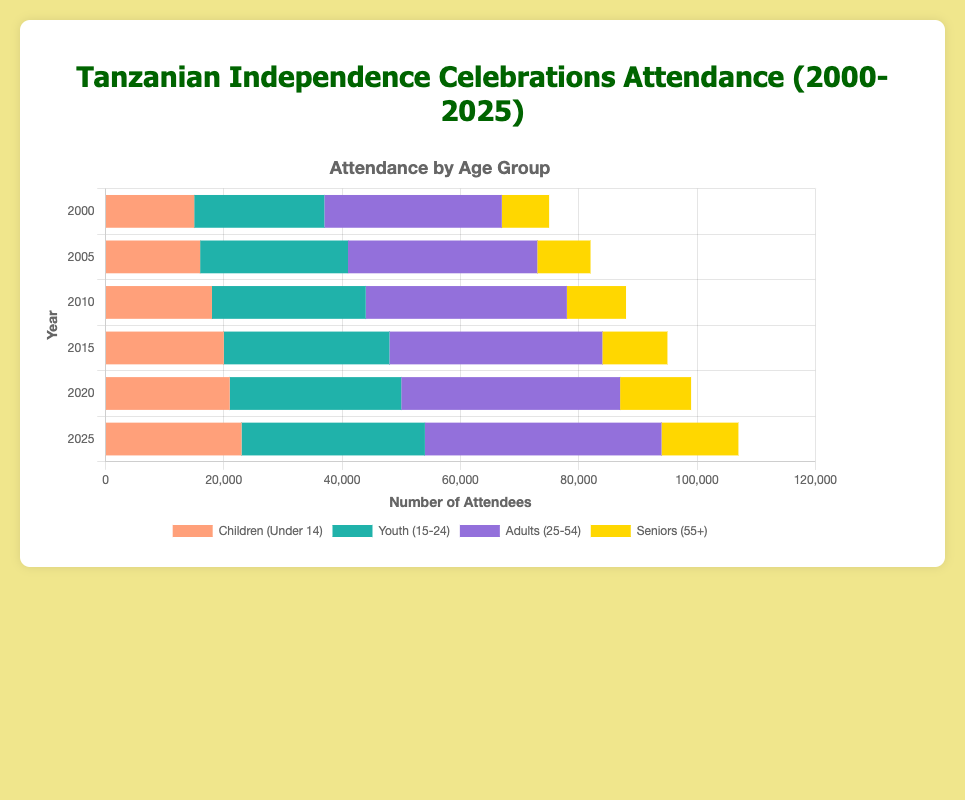What is the total attendance in the year 2010? To find the total attendance for 2010, sum the number of attendees in each age group: 18,000 (Children) + 26,000 (Youth) + 34,000 (Adults) + 10,000 (Seniors) = 88,000.
Answer: 88,000 Which age group had the highest number of attendees in 2020? In 2020, the number of attendees for each age group is: Children: 21,000, Youth: 29,000, Adults: 37,000, Seniors: 12,000. The highest attendance is among Adults with 37,000 attendees.
Answer: Adults How did the attendance of children under 14 change from 2005 to 2025? The attendance of children in 2005 was 16,000, and in 2025 it was 23,000. The change in attendance is 23,000 - 16,000 = 7,000.
Answer: Increased by 7,000 What is the average attendance for seniors (55+) over the years presented? To find the average, first sum the attendance numbers for seniors across all years: 8,000 (2000) + 9,000 (2005) + 10,000 (2010) + 11,000 (2015) + 12,000 (2020) + 13,000 (2025) = 63,000. Then divide by the number of years (6): 63,000 / 6 = 10,500.
Answer: 10,500 Between 2010 and 2015, which age group saw the largest increase in attendance? Calculate the attendance increase for each age group: Children: 20,000 - 18,000 = 2,000, Youth: 28,000 - 26,000 = 2,000, Adults: 36,000 - 34,000 = 2,000, Seniors: 11,000 - 10,000 = 1,000. The largest increase is 2,000, which is tied between Children, Youth, and Adults.
Answer: Children, Youth, and Adults (tie) What percentage of the total attendance in 2025 were adults (25-54)? First, calculate the total attendance in 2025: 23,000 (Children) + 31,000 (Youth) + 40,000 (Adults) + 13,000 (Seniors) = 107,000. Then find the percentage for adults: (40,000/107,000) * 100 ≈ 37.38%.
Answer: 37.38% Compare the number of children under 14 in 2000 and 2025. Which year had more attendees and by how much? In 2000, there were 15,000 children and in 2025 there were 23,000 children. The difference is 23,000 - 15,000 = 8,000. Thus, 2025 had more attendees by 8,000.
Answer: 2025 by 8,000 Which age group had the smallest increase in attendance from 2000 to 2025? Calculate the increase for each age group from 2000 to 2025: Children: 23,000 - 15,000 = 8,000, Youth: 31,000 - 22,000 = 9,000, Adults: 40,000 - 30,000 = 10,000, Seniors: 13,000 - 8,000 = 5,000. The smallest increase is among Seniors with 5,000.
Answer: Seniors In which year did the youth (15-24) attendance exceed 28,000 for the first time? By examining each year's data, the youth attendance first exceeded 28,000 in 2015 when it reached 28,000.
Answer: 2015 